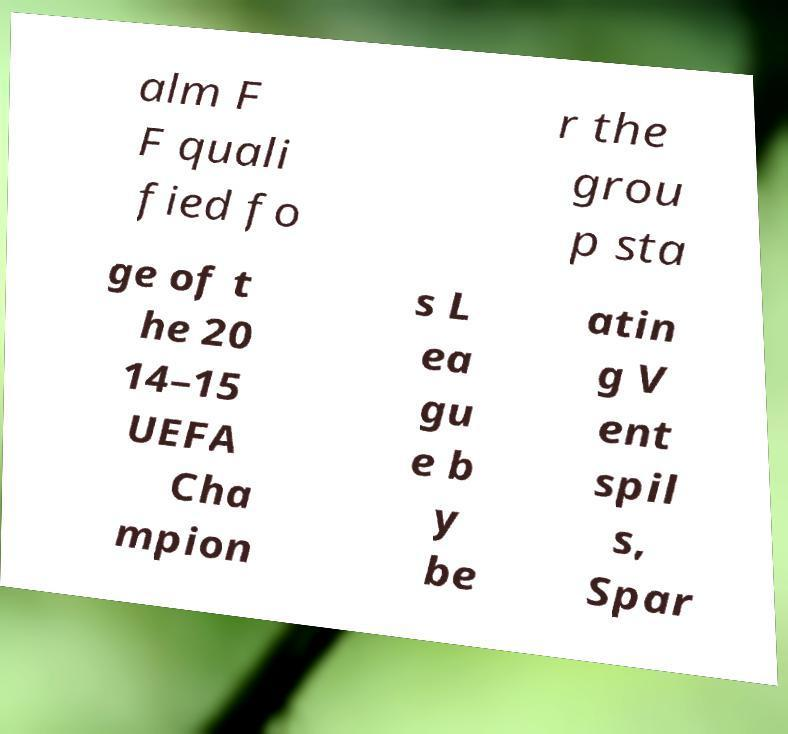Can you accurately transcribe the text from the provided image for me? alm F F quali fied fo r the grou p sta ge of t he 20 14–15 UEFA Cha mpion s L ea gu e b y be atin g V ent spil s, Spar 